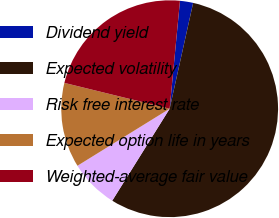Convert chart. <chart><loc_0><loc_0><loc_500><loc_500><pie_chart><fcel>Dividend yield<fcel>Expected volatility<fcel>Risk free interest rate<fcel>Expected option life in years<fcel>Weighted-average fair value<nl><fcel>1.96%<fcel>55.41%<fcel>7.3%<fcel>12.65%<fcel>22.69%<nl></chart> 